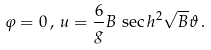Convert formula to latex. <formula><loc_0><loc_0><loc_500><loc_500>\varphi = 0 \, , \, u = \frac { 6 } { g } B \, \sec h ^ { 2 } \sqrt { B } \vartheta \, .</formula> 